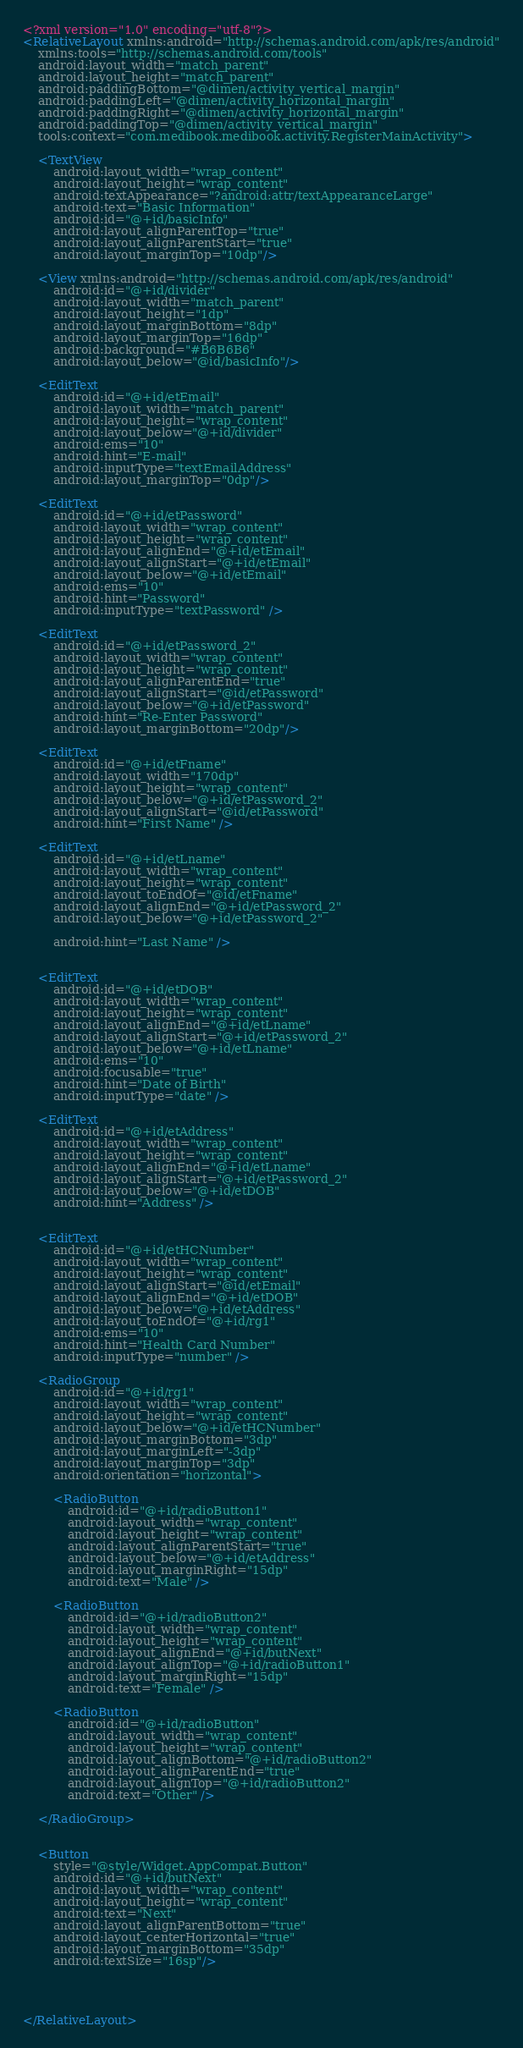Convert code to text. <code><loc_0><loc_0><loc_500><loc_500><_XML_><?xml version="1.0" encoding="utf-8"?>
<RelativeLayout xmlns:android="http://schemas.android.com/apk/res/android"
    xmlns:tools="http://schemas.android.com/tools"
    android:layout_width="match_parent"
    android:layout_height="match_parent"
    android:paddingBottom="@dimen/activity_vertical_margin"
    android:paddingLeft="@dimen/activity_horizontal_margin"
    android:paddingRight="@dimen/activity_horizontal_margin"
    android:paddingTop="@dimen/activity_vertical_margin"
    tools:context="com.medibook.medibook.activity.RegisterMainActivity">

    <TextView
        android:layout_width="wrap_content"
        android:layout_height="wrap_content"
        android:textAppearance="?android:attr/textAppearanceLarge"
        android:text="Basic Information"
        android:id="@+id/basicInfo"
        android:layout_alignParentTop="true"
        android:layout_alignParentStart="true"
        android:layout_marginTop="10dp"/>

    <View xmlns:android="http://schemas.android.com/apk/res/android"
        android:id="@+id/divider"
        android:layout_width="match_parent"
        android:layout_height="1dp"
        android:layout_marginBottom="8dp"
        android:layout_marginTop="16dp"
        android:background="#B6B6B6"
        android:layout_below="@id/basicInfo"/>

    <EditText
        android:id="@+id/etEmail"
        android:layout_width="match_parent"
        android:layout_height="wrap_content"
        android:layout_below="@+id/divider"
        android:ems="10"
        android:hint="E-mail"
        android:inputType="textEmailAddress"
        android:layout_marginTop="0dp"/>

    <EditText
        android:id="@+id/etPassword"
        android:layout_width="wrap_content"
        android:layout_height="wrap_content"
        android:layout_alignEnd="@+id/etEmail"
        android:layout_alignStart="@+id/etEmail"
        android:layout_below="@+id/etEmail"
        android:ems="10"
        android:hint="Password"
        android:inputType="textPassword" />

    <EditText
        android:id="@+id/etPassword_2"
        android:layout_width="wrap_content"
        android:layout_height="wrap_content"
        android:layout_alignParentEnd="true"
        android:layout_alignStart="@id/etPassword"
        android:layout_below="@+id/etPassword"
        android:hint="Re-Enter Password"
        android:layout_marginBottom="20dp"/>

    <EditText
        android:id="@+id/etFname"
        android:layout_width="170dp"
        android:layout_height="wrap_content"
        android:layout_below="@+id/etPassword_2"
        android:layout_alignStart="@id/etPassword"
        android:hint="First Name" />

    <EditText
        android:id="@+id/etLname"
        android:layout_width="wrap_content"
        android:layout_height="wrap_content"
        android:layout_toEndOf="@id/etFname"
        android:layout_alignEnd="@+id/etPassword_2"
        android:layout_below="@+id/etPassword_2"

        android:hint="Last Name" />


    <EditText
        android:id="@+id/etDOB"
        android:layout_width="wrap_content"
        android:layout_height="wrap_content"
        android:layout_alignEnd="@+id/etLname"
        android:layout_alignStart="@+id/etPassword_2"
        android:layout_below="@+id/etLname"
        android:ems="10"
        android:focusable="true"
        android:hint="Date of Birth"
        android:inputType="date" />

    <EditText
        android:id="@+id/etAddress"
        android:layout_width="wrap_content"
        android:layout_height="wrap_content"
        android:layout_alignEnd="@+id/etLname"
        android:layout_alignStart="@+id/etPassword_2"
        android:layout_below="@+id/etDOB"
        android:hint="Address" />


    <EditText
        android:id="@+id/etHCNumber"
        android:layout_width="wrap_content"
        android:layout_height="wrap_content"
        android:layout_alignStart="@id/etEmail"
        android:layout_alignEnd="@+id/etDOB"
        android:layout_below="@+id/etAddress"
        android:layout_toEndOf="@+id/rg1"
        android:ems="10"
        android:hint="Health Card Number"
        android:inputType="number" />

    <RadioGroup
        android:id="@+id/rg1"
        android:layout_width="wrap_content"
        android:layout_height="wrap_content"
        android:layout_below="@+id/etHCNumber"
        android:layout_marginBottom="3dp"
        android:layout_marginLeft="-3dp"
        android:layout_marginTop="3dp"
        android:orientation="horizontal">

        <RadioButton
            android:id="@+id/radioButton1"
            android:layout_width="wrap_content"
            android:layout_height="wrap_content"
            android:layout_alignParentStart="true"
            android:layout_below="@+id/etAddress"
            android:layout_marginRight="15dp"
            android:text="Male" />

        <RadioButton
            android:id="@+id/radioButton2"
            android:layout_width="wrap_content"
            android:layout_height="wrap_content"
            android:layout_alignEnd="@+id/butNext"
            android:layout_alignTop="@+id/radioButton1"
            android:layout_marginRight="15dp"
            android:text="Female" />

        <RadioButton
            android:id="@+id/radioButton"
            android:layout_width="wrap_content"
            android:layout_height="wrap_content"
            android:layout_alignBottom="@+id/radioButton2"
            android:layout_alignParentEnd="true"
            android:layout_alignTop="@+id/radioButton2"
            android:text="Other" />

    </RadioGroup>


    <Button
        style="@style/Widget.AppCompat.Button"
        android:id="@+id/butNext"
        android:layout_width="wrap_content"
        android:layout_height="wrap_content"
        android:text="Next"
        android:layout_alignParentBottom="true"
        android:layout_centerHorizontal="true"
        android:layout_marginBottom="35dp"
        android:textSize="16sp"/>




</RelativeLayout>
</code> 